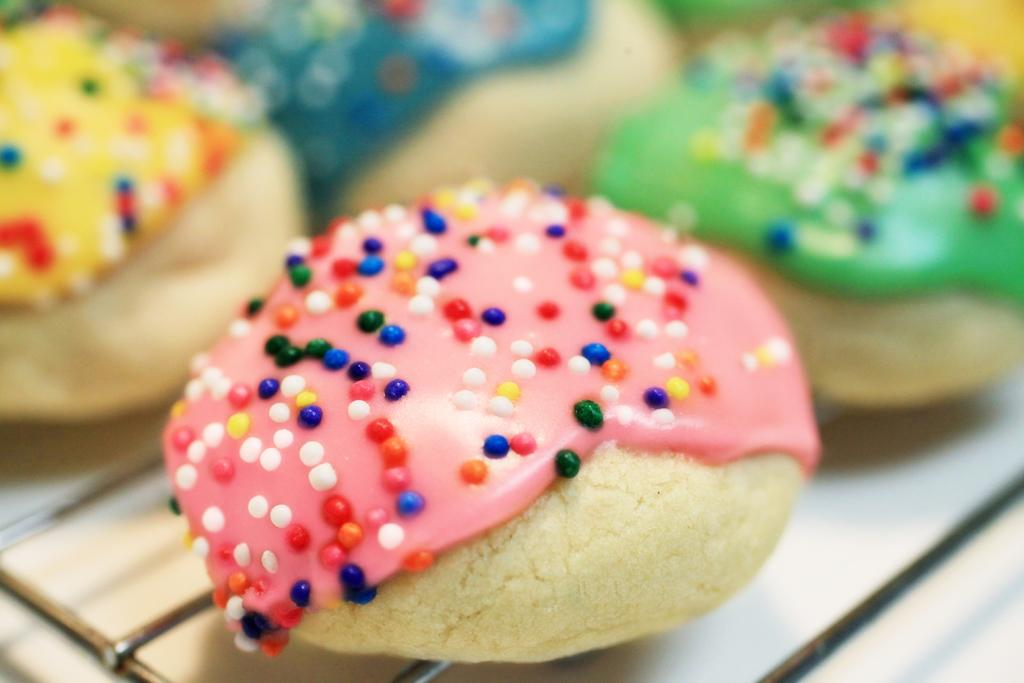What can be seen in the image related to food? There are food items in the image. How are the food items decorated? The food items are decorated with different color creams. Where are the food items placed? The food items are on a table. What type of train can be seen passing by the food items in the image? There is no train present in the image; it only features food items decorated with different color creams on a table. 